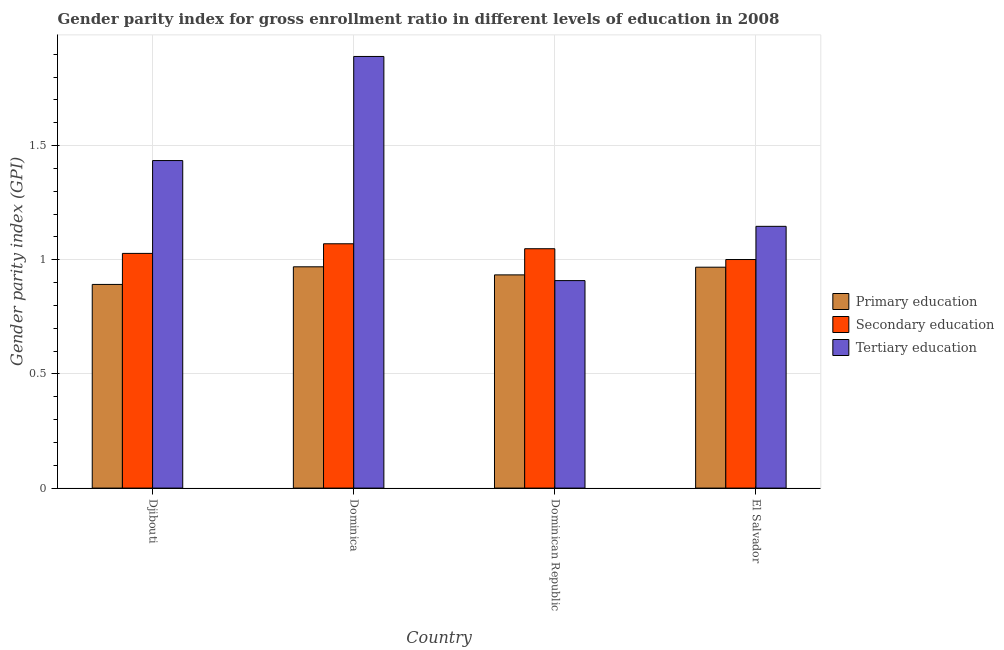How many groups of bars are there?
Offer a very short reply. 4. Are the number of bars per tick equal to the number of legend labels?
Offer a very short reply. Yes. Are the number of bars on each tick of the X-axis equal?
Your answer should be very brief. Yes. How many bars are there on the 1st tick from the right?
Keep it short and to the point. 3. What is the label of the 2nd group of bars from the left?
Provide a short and direct response. Dominica. What is the gender parity index in primary education in Dominican Republic?
Your answer should be compact. 0.93. Across all countries, what is the maximum gender parity index in secondary education?
Offer a terse response. 1.07. Across all countries, what is the minimum gender parity index in primary education?
Provide a short and direct response. 0.89. In which country was the gender parity index in secondary education maximum?
Your answer should be very brief. Dominica. In which country was the gender parity index in tertiary education minimum?
Offer a very short reply. Dominican Republic. What is the total gender parity index in secondary education in the graph?
Keep it short and to the point. 4.15. What is the difference between the gender parity index in secondary education in Djibouti and that in El Salvador?
Ensure brevity in your answer.  0.03. What is the difference between the gender parity index in primary education in Dominica and the gender parity index in tertiary education in Dominican Republic?
Offer a terse response. 0.06. What is the average gender parity index in secondary education per country?
Ensure brevity in your answer.  1.04. What is the difference between the gender parity index in tertiary education and gender parity index in primary education in Dominica?
Offer a very short reply. 0.92. What is the ratio of the gender parity index in secondary education in Dominica to that in El Salvador?
Offer a terse response. 1.07. What is the difference between the highest and the second highest gender parity index in tertiary education?
Offer a very short reply. 0.46. What is the difference between the highest and the lowest gender parity index in primary education?
Your response must be concise. 0.08. Is the sum of the gender parity index in tertiary education in Djibouti and Dominica greater than the maximum gender parity index in primary education across all countries?
Provide a succinct answer. Yes. What does the 3rd bar from the left in Dominican Republic represents?
Offer a terse response. Tertiary education. What does the 1st bar from the right in Dominica represents?
Give a very brief answer. Tertiary education. Is it the case that in every country, the sum of the gender parity index in primary education and gender parity index in secondary education is greater than the gender parity index in tertiary education?
Make the answer very short. Yes. How many bars are there?
Provide a short and direct response. 12. Are all the bars in the graph horizontal?
Provide a succinct answer. No. How many countries are there in the graph?
Provide a short and direct response. 4. Are the values on the major ticks of Y-axis written in scientific E-notation?
Make the answer very short. No. Does the graph contain any zero values?
Keep it short and to the point. No. Does the graph contain grids?
Keep it short and to the point. Yes. Where does the legend appear in the graph?
Offer a very short reply. Center right. How are the legend labels stacked?
Your response must be concise. Vertical. What is the title of the graph?
Offer a terse response. Gender parity index for gross enrollment ratio in different levels of education in 2008. What is the label or title of the Y-axis?
Offer a very short reply. Gender parity index (GPI). What is the Gender parity index (GPI) in Primary education in Djibouti?
Ensure brevity in your answer.  0.89. What is the Gender parity index (GPI) of Secondary education in Djibouti?
Offer a terse response. 1.03. What is the Gender parity index (GPI) of Tertiary education in Djibouti?
Ensure brevity in your answer.  1.43. What is the Gender parity index (GPI) of Primary education in Dominica?
Your answer should be very brief. 0.97. What is the Gender parity index (GPI) in Secondary education in Dominica?
Make the answer very short. 1.07. What is the Gender parity index (GPI) in Tertiary education in Dominica?
Give a very brief answer. 1.89. What is the Gender parity index (GPI) in Primary education in Dominican Republic?
Your answer should be compact. 0.93. What is the Gender parity index (GPI) of Secondary education in Dominican Republic?
Make the answer very short. 1.05. What is the Gender parity index (GPI) in Tertiary education in Dominican Republic?
Make the answer very short. 0.91. What is the Gender parity index (GPI) in Primary education in El Salvador?
Your response must be concise. 0.97. What is the Gender parity index (GPI) in Secondary education in El Salvador?
Make the answer very short. 1. What is the Gender parity index (GPI) of Tertiary education in El Salvador?
Make the answer very short. 1.15. Across all countries, what is the maximum Gender parity index (GPI) of Primary education?
Ensure brevity in your answer.  0.97. Across all countries, what is the maximum Gender parity index (GPI) of Secondary education?
Your answer should be compact. 1.07. Across all countries, what is the maximum Gender parity index (GPI) of Tertiary education?
Keep it short and to the point. 1.89. Across all countries, what is the minimum Gender parity index (GPI) of Primary education?
Give a very brief answer. 0.89. Across all countries, what is the minimum Gender parity index (GPI) in Secondary education?
Give a very brief answer. 1. Across all countries, what is the minimum Gender parity index (GPI) of Tertiary education?
Your response must be concise. 0.91. What is the total Gender parity index (GPI) in Primary education in the graph?
Your answer should be compact. 3.76. What is the total Gender parity index (GPI) of Secondary education in the graph?
Offer a very short reply. 4.15. What is the total Gender parity index (GPI) in Tertiary education in the graph?
Make the answer very short. 5.38. What is the difference between the Gender parity index (GPI) of Primary education in Djibouti and that in Dominica?
Provide a succinct answer. -0.08. What is the difference between the Gender parity index (GPI) in Secondary education in Djibouti and that in Dominica?
Give a very brief answer. -0.04. What is the difference between the Gender parity index (GPI) of Tertiary education in Djibouti and that in Dominica?
Offer a very short reply. -0.46. What is the difference between the Gender parity index (GPI) in Primary education in Djibouti and that in Dominican Republic?
Your answer should be very brief. -0.04. What is the difference between the Gender parity index (GPI) of Secondary education in Djibouti and that in Dominican Republic?
Provide a short and direct response. -0.02. What is the difference between the Gender parity index (GPI) in Tertiary education in Djibouti and that in Dominican Republic?
Make the answer very short. 0.53. What is the difference between the Gender parity index (GPI) of Primary education in Djibouti and that in El Salvador?
Make the answer very short. -0.08. What is the difference between the Gender parity index (GPI) of Secondary education in Djibouti and that in El Salvador?
Provide a short and direct response. 0.03. What is the difference between the Gender parity index (GPI) in Tertiary education in Djibouti and that in El Salvador?
Provide a succinct answer. 0.29. What is the difference between the Gender parity index (GPI) in Primary education in Dominica and that in Dominican Republic?
Your answer should be compact. 0.04. What is the difference between the Gender parity index (GPI) in Secondary education in Dominica and that in Dominican Republic?
Give a very brief answer. 0.02. What is the difference between the Gender parity index (GPI) in Tertiary education in Dominica and that in Dominican Republic?
Provide a succinct answer. 0.98. What is the difference between the Gender parity index (GPI) of Primary education in Dominica and that in El Salvador?
Offer a very short reply. 0. What is the difference between the Gender parity index (GPI) of Secondary education in Dominica and that in El Salvador?
Give a very brief answer. 0.07. What is the difference between the Gender parity index (GPI) in Tertiary education in Dominica and that in El Salvador?
Your answer should be compact. 0.74. What is the difference between the Gender parity index (GPI) of Primary education in Dominican Republic and that in El Salvador?
Offer a very short reply. -0.03. What is the difference between the Gender parity index (GPI) in Secondary education in Dominican Republic and that in El Salvador?
Keep it short and to the point. 0.05. What is the difference between the Gender parity index (GPI) in Tertiary education in Dominican Republic and that in El Salvador?
Provide a succinct answer. -0.24. What is the difference between the Gender parity index (GPI) of Primary education in Djibouti and the Gender parity index (GPI) of Secondary education in Dominica?
Provide a succinct answer. -0.18. What is the difference between the Gender parity index (GPI) of Primary education in Djibouti and the Gender parity index (GPI) of Tertiary education in Dominica?
Your answer should be compact. -1. What is the difference between the Gender parity index (GPI) of Secondary education in Djibouti and the Gender parity index (GPI) of Tertiary education in Dominica?
Provide a short and direct response. -0.86. What is the difference between the Gender parity index (GPI) in Primary education in Djibouti and the Gender parity index (GPI) in Secondary education in Dominican Republic?
Provide a succinct answer. -0.16. What is the difference between the Gender parity index (GPI) in Primary education in Djibouti and the Gender parity index (GPI) in Tertiary education in Dominican Republic?
Make the answer very short. -0.02. What is the difference between the Gender parity index (GPI) of Secondary education in Djibouti and the Gender parity index (GPI) of Tertiary education in Dominican Republic?
Make the answer very short. 0.12. What is the difference between the Gender parity index (GPI) in Primary education in Djibouti and the Gender parity index (GPI) in Secondary education in El Salvador?
Make the answer very short. -0.11. What is the difference between the Gender parity index (GPI) in Primary education in Djibouti and the Gender parity index (GPI) in Tertiary education in El Salvador?
Keep it short and to the point. -0.25. What is the difference between the Gender parity index (GPI) of Secondary education in Djibouti and the Gender parity index (GPI) of Tertiary education in El Salvador?
Make the answer very short. -0.12. What is the difference between the Gender parity index (GPI) of Primary education in Dominica and the Gender parity index (GPI) of Secondary education in Dominican Republic?
Offer a very short reply. -0.08. What is the difference between the Gender parity index (GPI) in Primary education in Dominica and the Gender parity index (GPI) in Tertiary education in Dominican Republic?
Offer a terse response. 0.06. What is the difference between the Gender parity index (GPI) of Secondary education in Dominica and the Gender parity index (GPI) of Tertiary education in Dominican Republic?
Provide a succinct answer. 0.16. What is the difference between the Gender parity index (GPI) in Primary education in Dominica and the Gender parity index (GPI) in Secondary education in El Salvador?
Offer a very short reply. -0.03. What is the difference between the Gender parity index (GPI) of Primary education in Dominica and the Gender parity index (GPI) of Tertiary education in El Salvador?
Provide a succinct answer. -0.18. What is the difference between the Gender parity index (GPI) of Secondary education in Dominica and the Gender parity index (GPI) of Tertiary education in El Salvador?
Provide a succinct answer. -0.08. What is the difference between the Gender parity index (GPI) of Primary education in Dominican Republic and the Gender parity index (GPI) of Secondary education in El Salvador?
Your response must be concise. -0.07. What is the difference between the Gender parity index (GPI) of Primary education in Dominican Republic and the Gender parity index (GPI) of Tertiary education in El Salvador?
Keep it short and to the point. -0.21. What is the difference between the Gender parity index (GPI) in Secondary education in Dominican Republic and the Gender parity index (GPI) in Tertiary education in El Salvador?
Provide a succinct answer. -0.1. What is the average Gender parity index (GPI) in Primary education per country?
Your answer should be very brief. 0.94. What is the average Gender parity index (GPI) in Secondary education per country?
Offer a terse response. 1.04. What is the average Gender parity index (GPI) in Tertiary education per country?
Ensure brevity in your answer.  1.35. What is the difference between the Gender parity index (GPI) in Primary education and Gender parity index (GPI) in Secondary education in Djibouti?
Your answer should be very brief. -0.14. What is the difference between the Gender parity index (GPI) of Primary education and Gender parity index (GPI) of Tertiary education in Djibouti?
Provide a succinct answer. -0.54. What is the difference between the Gender parity index (GPI) in Secondary education and Gender parity index (GPI) in Tertiary education in Djibouti?
Ensure brevity in your answer.  -0.41. What is the difference between the Gender parity index (GPI) of Primary education and Gender parity index (GPI) of Secondary education in Dominica?
Your response must be concise. -0.1. What is the difference between the Gender parity index (GPI) in Primary education and Gender parity index (GPI) in Tertiary education in Dominica?
Keep it short and to the point. -0.92. What is the difference between the Gender parity index (GPI) in Secondary education and Gender parity index (GPI) in Tertiary education in Dominica?
Your answer should be very brief. -0.82. What is the difference between the Gender parity index (GPI) in Primary education and Gender parity index (GPI) in Secondary education in Dominican Republic?
Your answer should be compact. -0.11. What is the difference between the Gender parity index (GPI) of Primary education and Gender parity index (GPI) of Tertiary education in Dominican Republic?
Offer a terse response. 0.03. What is the difference between the Gender parity index (GPI) in Secondary education and Gender parity index (GPI) in Tertiary education in Dominican Republic?
Your answer should be very brief. 0.14. What is the difference between the Gender parity index (GPI) of Primary education and Gender parity index (GPI) of Secondary education in El Salvador?
Your response must be concise. -0.03. What is the difference between the Gender parity index (GPI) in Primary education and Gender parity index (GPI) in Tertiary education in El Salvador?
Provide a short and direct response. -0.18. What is the difference between the Gender parity index (GPI) in Secondary education and Gender parity index (GPI) in Tertiary education in El Salvador?
Give a very brief answer. -0.15. What is the ratio of the Gender parity index (GPI) in Primary education in Djibouti to that in Dominica?
Provide a succinct answer. 0.92. What is the ratio of the Gender parity index (GPI) in Secondary education in Djibouti to that in Dominica?
Provide a short and direct response. 0.96. What is the ratio of the Gender parity index (GPI) of Tertiary education in Djibouti to that in Dominica?
Ensure brevity in your answer.  0.76. What is the ratio of the Gender parity index (GPI) of Primary education in Djibouti to that in Dominican Republic?
Offer a terse response. 0.96. What is the ratio of the Gender parity index (GPI) of Secondary education in Djibouti to that in Dominican Republic?
Your response must be concise. 0.98. What is the ratio of the Gender parity index (GPI) in Tertiary education in Djibouti to that in Dominican Republic?
Offer a terse response. 1.58. What is the ratio of the Gender parity index (GPI) in Primary education in Djibouti to that in El Salvador?
Provide a short and direct response. 0.92. What is the ratio of the Gender parity index (GPI) of Secondary education in Djibouti to that in El Salvador?
Offer a terse response. 1.03. What is the ratio of the Gender parity index (GPI) of Tertiary education in Djibouti to that in El Salvador?
Give a very brief answer. 1.25. What is the ratio of the Gender parity index (GPI) of Primary education in Dominica to that in Dominican Republic?
Ensure brevity in your answer.  1.04. What is the ratio of the Gender parity index (GPI) in Secondary education in Dominica to that in Dominican Republic?
Make the answer very short. 1.02. What is the ratio of the Gender parity index (GPI) of Tertiary education in Dominica to that in Dominican Republic?
Offer a very short reply. 2.08. What is the ratio of the Gender parity index (GPI) in Secondary education in Dominica to that in El Salvador?
Provide a succinct answer. 1.07. What is the ratio of the Gender parity index (GPI) of Tertiary education in Dominica to that in El Salvador?
Ensure brevity in your answer.  1.65. What is the ratio of the Gender parity index (GPI) in Primary education in Dominican Republic to that in El Salvador?
Give a very brief answer. 0.97. What is the ratio of the Gender parity index (GPI) of Secondary education in Dominican Republic to that in El Salvador?
Offer a very short reply. 1.05. What is the ratio of the Gender parity index (GPI) of Tertiary education in Dominican Republic to that in El Salvador?
Your response must be concise. 0.79. What is the difference between the highest and the second highest Gender parity index (GPI) in Primary education?
Your answer should be very brief. 0. What is the difference between the highest and the second highest Gender parity index (GPI) of Secondary education?
Ensure brevity in your answer.  0.02. What is the difference between the highest and the second highest Gender parity index (GPI) in Tertiary education?
Your answer should be compact. 0.46. What is the difference between the highest and the lowest Gender parity index (GPI) in Primary education?
Offer a terse response. 0.08. What is the difference between the highest and the lowest Gender parity index (GPI) in Secondary education?
Your answer should be very brief. 0.07. What is the difference between the highest and the lowest Gender parity index (GPI) of Tertiary education?
Your answer should be very brief. 0.98. 